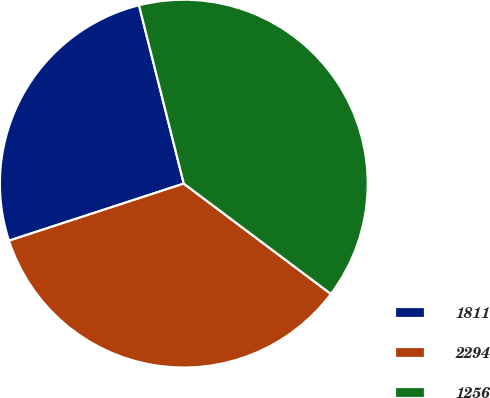<chart> <loc_0><loc_0><loc_500><loc_500><pie_chart><fcel>1811<fcel>2294<fcel>1256<nl><fcel>26.11%<fcel>34.74%<fcel>39.16%<nl></chart> 